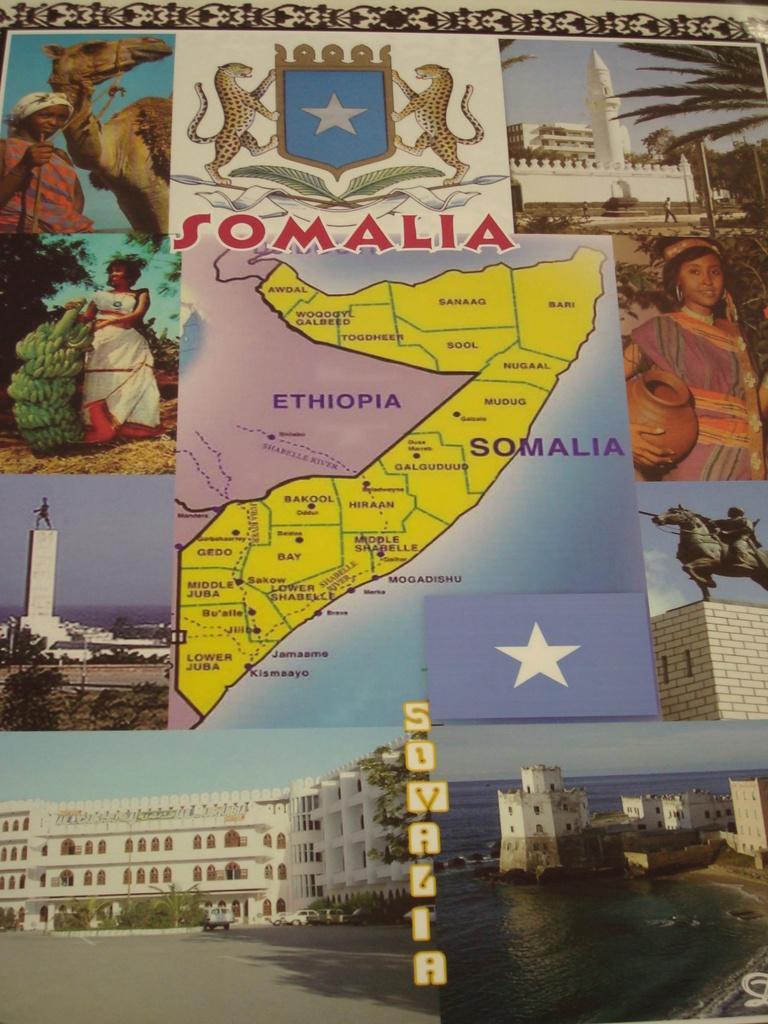What country is featured in yellow on the map?
Provide a succinct answer. Somalia. 